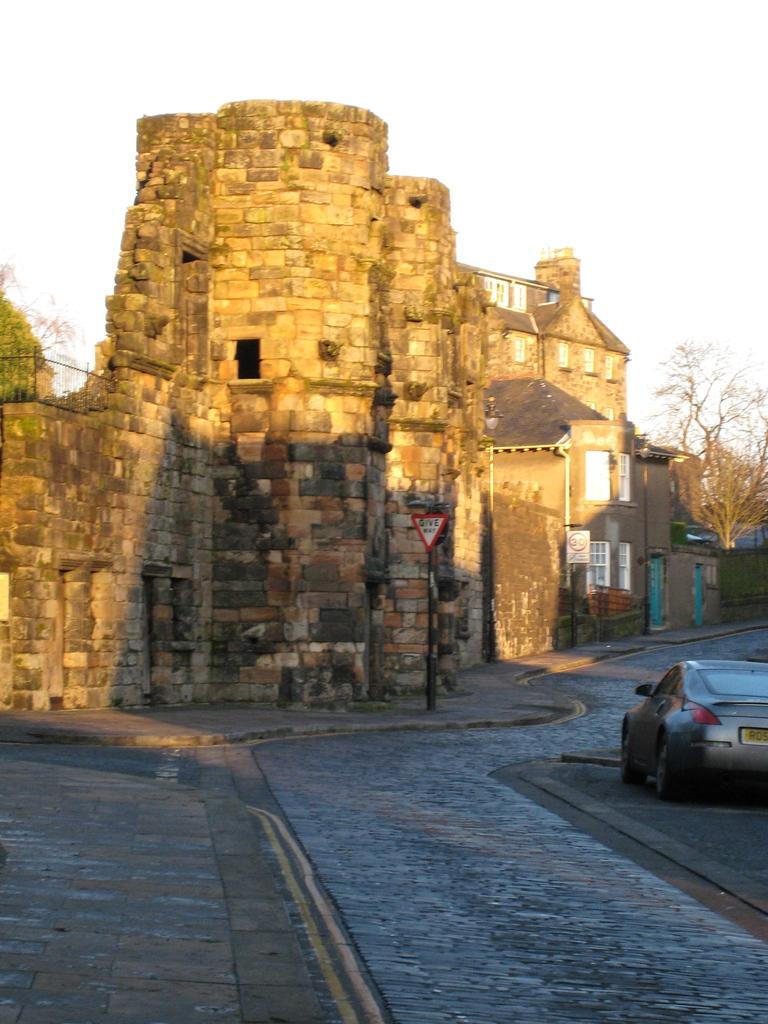Could you give a brief overview of what you see in this image? In this image we can see a building looks like a fort, there are few trees, a sign board on the pavement, a car on the road and the sky in the background. 